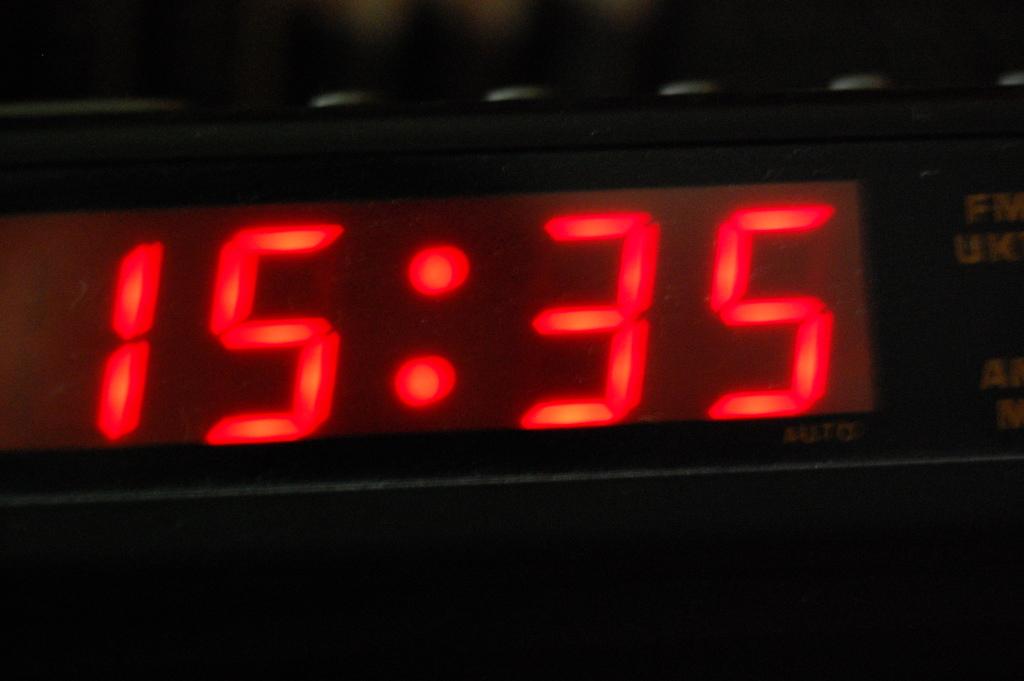What time is it?
Your response must be concise. 15:35. 